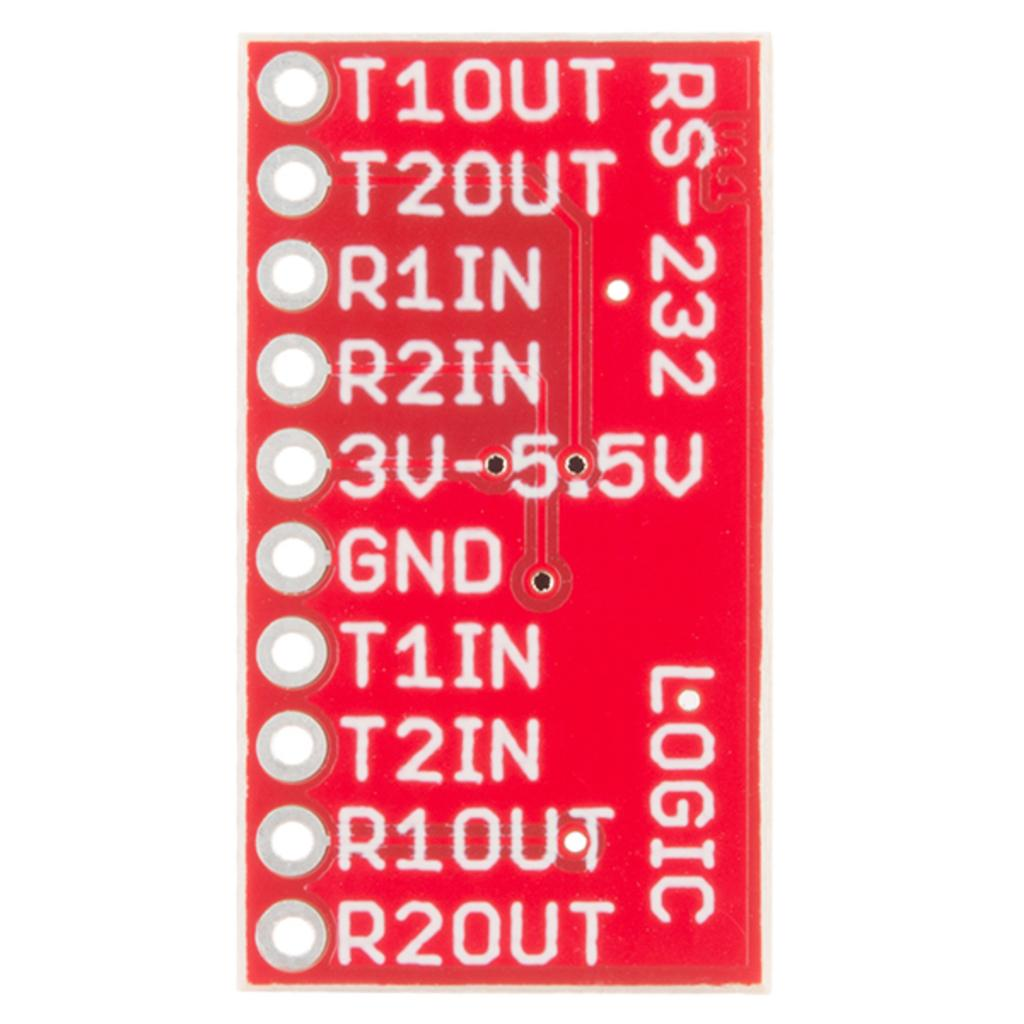<image>
Create a compact narrative representing the image presented. Red sign that says R2OUT in white on the bottom. 